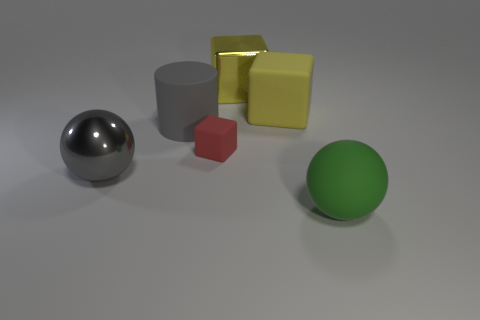How many other objects are the same size as the gray metallic object?
Offer a terse response. 4. Do the large rubber block and the large shiny block have the same color?
Offer a very short reply. Yes. There is a large ball right of the ball that is to the left of the rubber object that is on the left side of the small rubber object; what is its color?
Keep it short and to the point. Green. What number of cubes are on the right side of the tiny red object that is to the left of the big metal object that is to the right of the large cylinder?
Your response must be concise. 2. Is there any other thing of the same color as the small matte thing?
Your answer should be very brief. No. Does the ball that is behind the green rubber thing have the same size as the gray cylinder?
Offer a terse response. Yes. There is a ball that is behind the large green ball; how many small blocks are left of it?
Ensure brevity in your answer.  0. Are there any big cylinders that are behind the gray object on the right side of the big ball that is behind the large matte sphere?
Give a very brief answer. No. What is the material of the other large thing that is the same shape as the big gray metal object?
Offer a very short reply. Rubber. Does the cylinder have the same material as the ball right of the tiny matte thing?
Offer a terse response. Yes. 